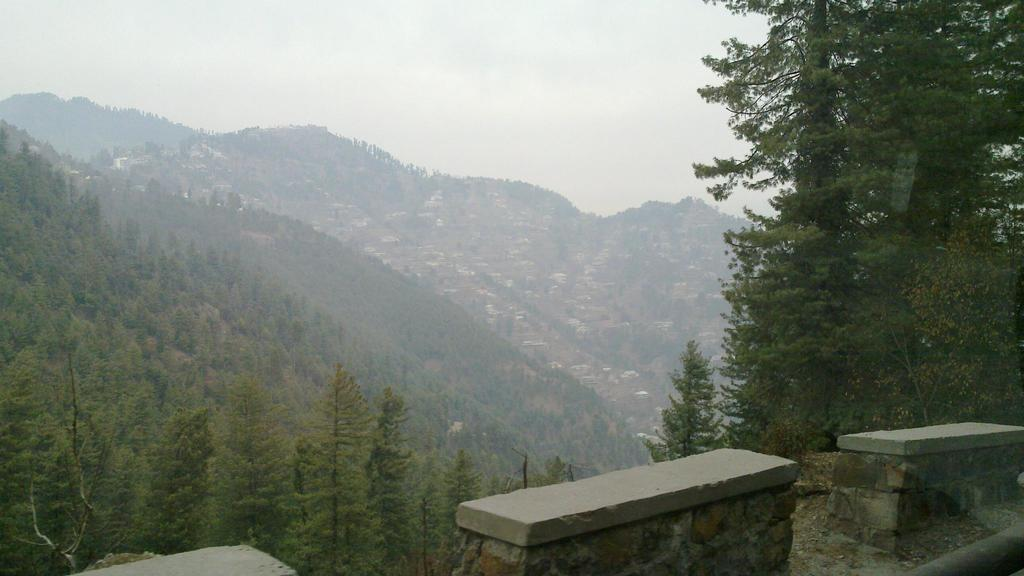What type of natural elements can be seen in the image? There are trees and hills in the image. What part of the natural environment is visible in the image? The sky is visible in the image. What objects are located at the bottom of the image? There are objects that resemble benches at the bottom of the image. What language is spoken by the trees in the image? Trees do not speak any language, so this question cannot be answered. 